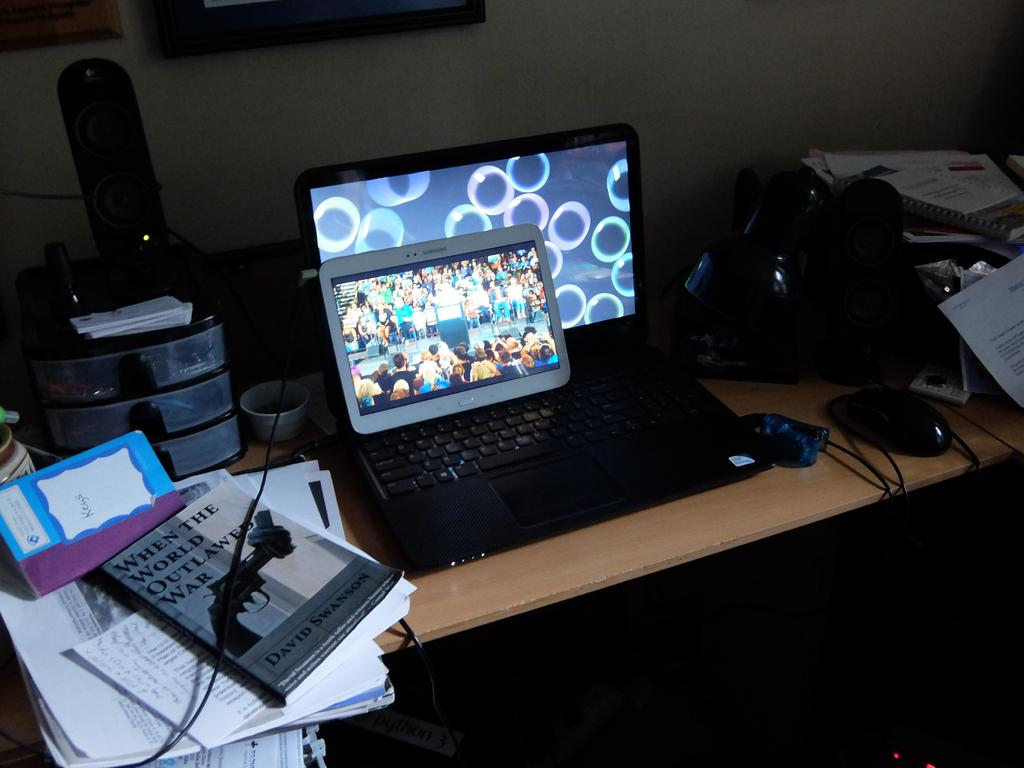<image>
Render a clear and concise summary of the photo. a tablet by samsung sitting on top of a laptop with a bubbles background 